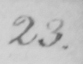Transcribe the text shown in this historical manuscript line. 23 . 